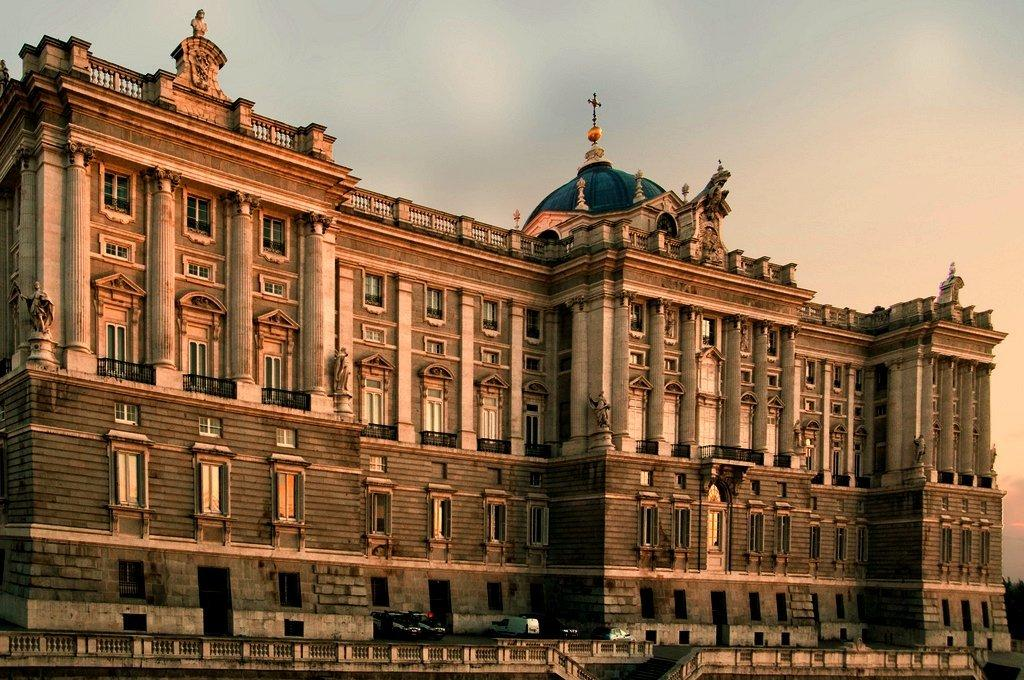What is the main structure in the image? There is a big building in the image. What can be seen near the building? There are cars parked in front of the building. What type of quiver is hanging on the wall inside the building? There is no quiver present in the image, as it only features a big building and parked cars. 